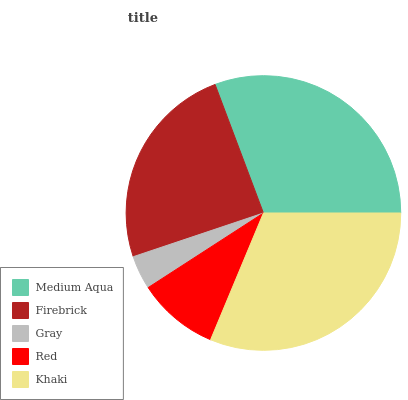Is Gray the minimum?
Answer yes or no. Yes. Is Khaki the maximum?
Answer yes or no. Yes. Is Firebrick the minimum?
Answer yes or no. No. Is Firebrick the maximum?
Answer yes or no. No. Is Medium Aqua greater than Firebrick?
Answer yes or no. Yes. Is Firebrick less than Medium Aqua?
Answer yes or no. Yes. Is Firebrick greater than Medium Aqua?
Answer yes or no. No. Is Medium Aqua less than Firebrick?
Answer yes or no. No. Is Firebrick the high median?
Answer yes or no. Yes. Is Firebrick the low median?
Answer yes or no. Yes. Is Gray the high median?
Answer yes or no. No. Is Red the low median?
Answer yes or no. No. 